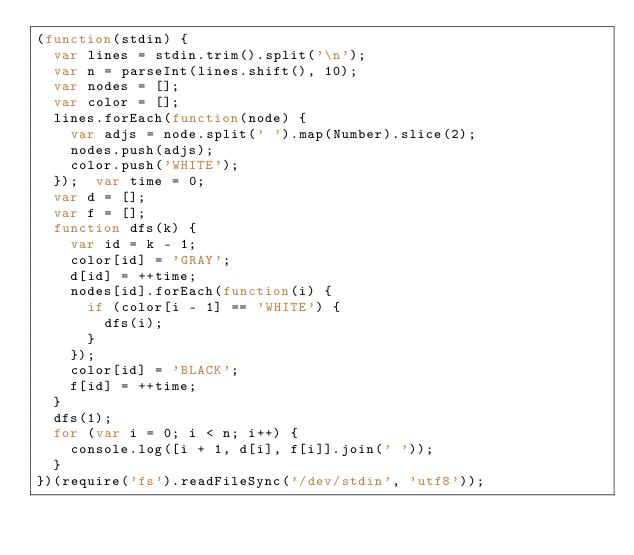<code> <loc_0><loc_0><loc_500><loc_500><_JavaScript_>(function(stdin) {
  var lines = stdin.trim().split('\n');
  var n = parseInt(lines.shift(), 10);
  var nodes = [];
  var color = [];
  lines.forEach(function(node) {
    var adjs = node.split(' ').map(Number).slice(2);
    nodes.push(adjs);
    color.push('WHITE');
  });  var time = 0;
  var d = [];
  var f = [];
  function dfs(k) {
    var id = k - 1;
    color[id] = 'GRAY';
    d[id] = ++time;
    nodes[id].forEach(function(i) {
      if (color[i - 1] == 'WHITE') {
        dfs(i);
      }
    });
    color[id] = 'BLACK';
    f[id] = ++time;
  }
  dfs(1);
  for (var i = 0; i < n; i++) {
    console.log([i + 1, d[i], f[i]].join(' '));
  }
})(require('fs').readFileSync('/dev/stdin', 'utf8'));</code> 